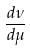<formula> <loc_0><loc_0><loc_500><loc_500>\frac { d \nu } { d \mu }</formula> 